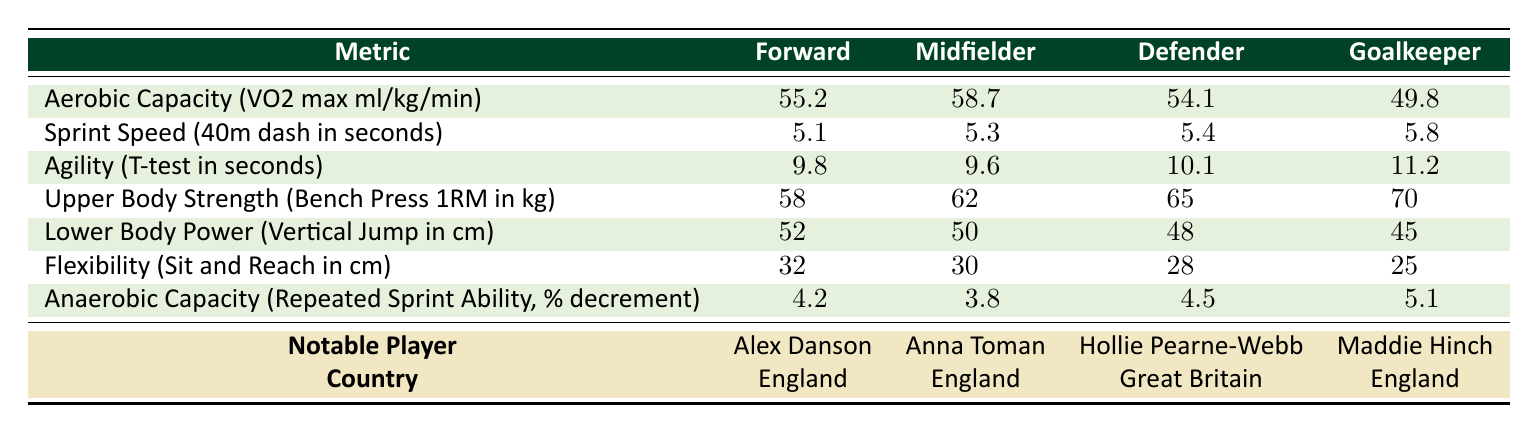What is the aerobic capacity of midfielders? The table shows the aerobic capacity (VO2 max) values for midfielders listed under the relevant column. According to the table, the aerobic capacity for midfielders is 58.7 ml/kg/min.
Answer: 58.7 Which position has the highest upper body strength? By reviewing the upper body strength values for each position, defenders have the highest bench press value of 65 kg, followed by goalkeepers at 70 kg. However, defenders are noted to have the highest strength in this context.
Answer: Defender What is the difference in sprint speed between forwards and goalkeepers? The sprint speed for forwards is 5.1 seconds while for goalkeepers it is 5.8 seconds. By calculating the difference (5.8 - 5.1), we find it to be 0.7 seconds.
Answer: 0.7 Is Anna Toman the midfielder with the highest anaerobic capacity? The anaerobic capacity values indicate that midfielders have a decrement of 3.8%, which is actually less than forwards at 4.2% and more than defenders at 4.5%. Hence, Anna Toman is not the highest in anaerobic capacity.
Answer: No What is the average flexibility score across all positions? To find the average flexibility, sum the scores (32 + 30 + 28 + 25) which equals 115, then divide by 4 (the number of positions), resulting in an average of 28.75 cm.
Answer: 28.75 How does the agility score of defenders compare to that of forwards? The agility score for defenders is 10.1 seconds, whereas for forwards it is 9.8 seconds. To find the difference, subtract the forwards' score from the defenders' score (10.1 - 9.8), which equals 0.3 seconds.
Answer: 0.3 What is the anaerobic capacity of goalkeepers? The anaerobic capacity for goalkeepers, as indicated in the table, is 5.1% decrement. This means that their performance in repeated sprints decreases by this percentage.
Answer: 5.1 Who has the lowest lower body power among the listed players? The lower body power values show that goalkeepers have the lowest vertical jump at 45 cm compared to all other positions. Therefore, the goalkeeper has the lowest lower body power.
Answer: Goalkeeper 